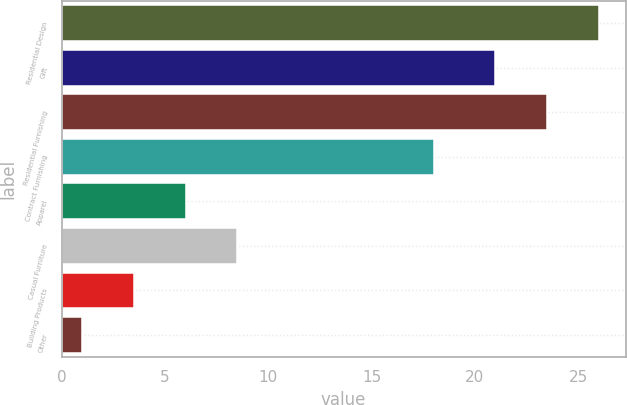Convert chart. <chart><loc_0><loc_0><loc_500><loc_500><bar_chart><fcel>Residential Design<fcel>Gift<fcel>Residential Furnishing<fcel>Contract Furnishing<fcel>Apparel<fcel>Casual Furniture<fcel>Building Products<fcel>Other<nl><fcel>26<fcel>21<fcel>23.5<fcel>18<fcel>6<fcel>8.5<fcel>3.5<fcel>1<nl></chart> 